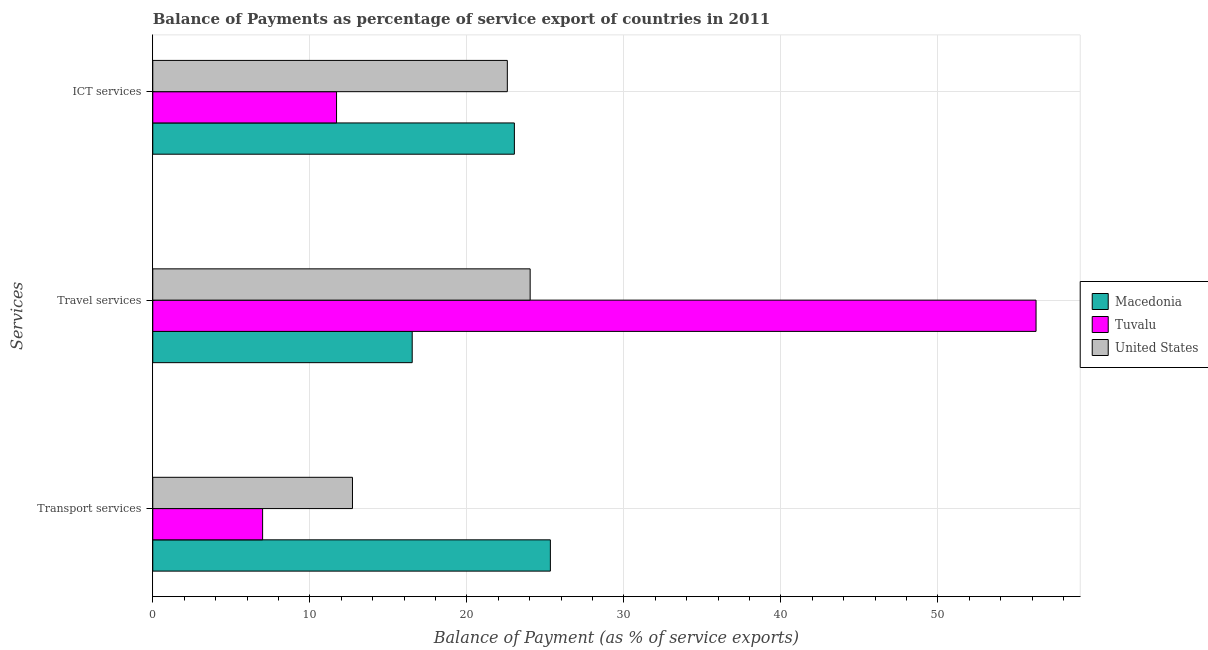How many different coloured bars are there?
Offer a terse response. 3. How many bars are there on the 3rd tick from the bottom?
Provide a short and direct response. 3. What is the label of the 1st group of bars from the top?
Offer a terse response. ICT services. What is the balance of payment of transport services in Macedonia?
Keep it short and to the point. 25.32. Across all countries, what is the maximum balance of payment of travel services?
Make the answer very short. 56.25. Across all countries, what is the minimum balance of payment of transport services?
Offer a very short reply. 6.99. In which country was the balance of payment of travel services maximum?
Offer a very short reply. Tuvalu. In which country was the balance of payment of transport services minimum?
Ensure brevity in your answer.  Tuvalu. What is the total balance of payment of transport services in the graph?
Keep it short and to the point. 45.03. What is the difference between the balance of payment of transport services in Tuvalu and that in Macedonia?
Your answer should be very brief. -18.32. What is the difference between the balance of payment of ict services in United States and the balance of payment of transport services in Macedonia?
Ensure brevity in your answer.  -2.74. What is the average balance of payment of ict services per country?
Provide a short and direct response. 19.1. What is the difference between the balance of payment of transport services and balance of payment of travel services in United States?
Ensure brevity in your answer.  -11.32. What is the ratio of the balance of payment of transport services in Macedonia to that in Tuvalu?
Give a very brief answer. 3.62. Is the balance of payment of transport services in United States less than that in Macedonia?
Your answer should be very brief. Yes. Is the difference between the balance of payment of transport services in United States and Macedonia greater than the difference between the balance of payment of travel services in United States and Macedonia?
Your answer should be very brief. No. What is the difference between the highest and the second highest balance of payment of transport services?
Your answer should be very brief. 12.6. What is the difference between the highest and the lowest balance of payment of transport services?
Make the answer very short. 18.32. What does the 2nd bar from the top in ICT services represents?
Offer a very short reply. Tuvalu. What does the 3rd bar from the bottom in ICT services represents?
Your response must be concise. United States. Is it the case that in every country, the sum of the balance of payment of transport services and balance of payment of travel services is greater than the balance of payment of ict services?
Make the answer very short. Yes. How many bars are there?
Provide a short and direct response. 9. How many countries are there in the graph?
Provide a succinct answer. 3. What is the difference between two consecutive major ticks on the X-axis?
Provide a short and direct response. 10. Does the graph contain any zero values?
Make the answer very short. No. Does the graph contain grids?
Your response must be concise. Yes. Where does the legend appear in the graph?
Offer a very short reply. Center right. How many legend labels are there?
Your answer should be compact. 3. How are the legend labels stacked?
Ensure brevity in your answer.  Vertical. What is the title of the graph?
Ensure brevity in your answer.  Balance of Payments as percentage of service export of countries in 2011. Does "Peru" appear as one of the legend labels in the graph?
Make the answer very short. No. What is the label or title of the X-axis?
Keep it short and to the point. Balance of Payment (as % of service exports). What is the label or title of the Y-axis?
Provide a succinct answer. Services. What is the Balance of Payment (as % of service exports) in Macedonia in Transport services?
Your answer should be very brief. 25.32. What is the Balance of Payment (as % of service exports) of Tuvalu in Transport services?
Offer a very short reply. 6.99. What is the Balance of Payment (as % of service exports) in United States in Transport services?
Make the answer very short. 12.72. What is the Balance of Payment (as % of service exports) in Macedonia in Travel services?
Your response must be concise. 16.52. What is the Balance of Payment (as % of service exports) in Tuvalu in Travel services?
Give a very brief answer. 56.25. What is the Balance of Payment (as % of service exports) of United States in Travel services?
Your answer should be very brief. 24.03. What is the Balance of Payment (as % of service exports) in Macedonia in ICT services?
Your response must be concise. 23.03. What is the Balance of Payment (as % of service exports) in Tuvalu in ICT services?
Provide a short and direct response. 11.7. What is the Balance of Payment (as % of service exports) in United States in ICT services?
Offer a very short reply. 22.58. Across all Services, what is the maximum Balance of Payment (as % of service exports) of Macedonia?
Ensure brevity in your answer.  25.32. Across all Services, what is the maximum Balance of Payment (as % of service exports) of Tuvalu?
Your answer should be very brief. 56.25. Across all Services, what is the maximum Balance of Payment (as % of service exports) in United States?
Make the answer very short. 24.03. Across all Services, what is the minimum Balance of Payment (as % of service exports) of Macedonia?
Provide a short and direct response. 16.52. Across all Services, what is the minimum Balance of Payment (as % of service exports) of Tuvalu?
Your answer should be compact. 6.99. Across all Services, what is the minimum Balance of Payment (as % of service exports) in United States?
Provide a succinct answer. 12.72. What is the total Balance of Payment (as % of service exports) in Macedonia in the graph?
Your response must be concise. 64.87. What is the total Balance of Payment (as % of service exports) in Tuvalu in the graph?
Provide a short and direct response. 74.94. What is the total Balance of Payment (as % of service exports) of United States in the graph?
Provide a succinct answer. 59.33. What is the difference between the Balance of Payment (as % of service exports) of Macedonia in Transport services and that in Travel services?
Make the answer very short. 8.8. What is the difference between the Balance of Payment (as % of service exports) in Tuvalu in Transport services and that in Travel services?
Offer a very short reply. -49.25. What is the difference between the Balance of Payment (as % of service exports) of United States in Transport services and that in Travel services?
Give a very brief answer. -11.32. What is the difference between the Balance of Payment (as % of service exports) in Macedonia in Transport services and that in ICT services?
Offer a very short reply. 2.29. What is the difference between the Balance of Payment (as % of service exports) of Tuvalu in Transport services and that in ICT services?
Give a very brief answer. -4.71. What is the difference between the Balance of Payment (as % of service exports) in United States in Transport services and that in ICT services?
Your answer should be compact. -9.86. What is the difference between the Balance of Payment (as % of service exports) in Macedonia in Travel services and that in ICT services?
Give a very brief answer. -6.51. What is the difference between the Balance of Payment (as % of service exports) of Tuvalu in Travel services and that in ICT services?
Provide a short and direct response. 44.54. What is the difference between the Balance of Payment (as % of service exports) of United States in Travel services and that in ICT services?
Your answer should be very brief. 1.45. What is the difference between the Balance of Payment (as % of service exports) in Macedonia in Transport services and the Balance of Payment (as % of service exports) in Tuvalu in Travel services?
Provide a succinct answer. -30.93. What is the difference between the Balance of Payment (as % of service exports) of Macedonia in Transport services and the Balance of Payment (as % of service exports) of United States in Travel services?
Your response must be concise. 1.29. What is the difference between the Balance of Payment (as % of service exports) in Tuvalu in Transport services and the Balance of Payment (as % of service exports) in United States in Travel services?
Your answer should be compact. -17.04. What is the difference between the Balance of Payment (as % of service exports) in Macedonia in Transport services and the Balance of Payment (as % of service exports) in Tuvalu in ICT services?
Make the answer very short. 13.62. What is the difference between the Balance of Payment (as % of service exports) in Macedonia in Transport services and the Balance of Payment (as % of service exports) in United States in ICT services?
Provide a succinct answer. 2.74. What is the difference between the Balance of Payment (as % of service exports) in Tuvalu in Transport services and the Balance of Payment (as % of service exports) in United States in ICT services?
Offer a terse response. -15.58. What is the difference between the Balance of Payment (as % of service exports) in Macedonia in Travel services and the Balance of Payment (as % of service exports) in Tuvalu in ICT services?
Give a very brief answer. 4.82. What is the difference between the Balance of Payment (as % of service exports) in Macedonia in Travel services and the Balance of Payment (as % of service exports) in United States in ICT services?
Ensure brevity in your answer.  -6.06. What is the difference between the Balance of Payment (as % of service exports) in Tuvalu in Travel services and the Balance of Payment (as % of service exports) in United States in ICT services?
Your response must be concise. 33.67. What is the average Balance of Payment (as % of service exports) of Macedonia per Services?
Offer a very short reply. 21.62. What is the average Balance of Payment (as % of service exports) of Tuvalu per Services?
Give a very brief answer. 24.98. What is the average Balance of Payment (as % of service exports) in United States per Services?
Provide a short and direct response. 19.78. What is the difference between the Balance of Payment (as % of service exports) in Macedonia and Balance of Payment (as % of service exports) in Tuvalu in Transport services?
Make the answer very short. 18.32. What is the difference between the Balance of Payment (as % of service exports) in Macedonia and Balance of Payment (as % of service exports) in United States in Transport services?
Your answer should be compact. 12.6. What is the difference between the Balance of Payment (as % of service exports) of Tuvalu and Balance of Payment (as % of service exports) of United States in Transport services?
Provide a short and direct response. -5.72. What is the difference between the Balance of Payment (as % of service exports) of Macedonia and Balance of Payment (as % of service exports) of Tuvalu in Travel services?
Offer a very short reply. -39.73. What is the difference between the Balance of Payment (as % of service exports) in Macedonia and Balance of Payment (as % of service exports) in United States in Travel services?
Offer a very short reply. -7.51. What is the difference between the Balance of Payment (as % of service exports) in Tuvalu and Balance of Payment (as % of service exports) in United States in Travel services?
Keep it short and to the point. 32.22. What is the difference between the Balance of Payment (as % of service exports) of Macedonia and Balance of Payment (as % of service exports) of Tuvalu in ICT services?
Your answer should be compact. 11.32. What is the difference between the Balance of Payment (as % of service exports) of Macedonia and Balance of Payment (as % of service exports) of United States in ICT services?
Ensure brevity in your answer.  0.45. What is the difference between the Balance of Payment (as % of service exports) of Tuvalu and Balance of Payment (as % of service exports) of United States in ICT services?
Offer a terse response. -10.88. What is the ratio of the Balance of Payment (as % of service exports) in Macedonia in Transport services to that in Travel services?
Offer a terse response. 1.53. What is the ratio of the Balance of Payment (as % of service exports) in Tuvalu in Transport services to that in Travel services?
Give a very brief answer. 0.12. What is the ratio of the Balance of Payment (as % of service exports) of United States in Transport services to that in Travel services?
Provide a succinct answer. 0.53. What is the ratio of the Balance of Payment (as % of service exports) in Macedonia in Transport services to that in ICT services?
Your answer should be compact. 1.1. What is the ratio of the Balance of Payment (as % of service exports) in Tuvalu in Transport services to that in ICT services?
Keep it short and to the point. 0.6. What is the ratio of the Balance of Payment (as % of service exports) of United States in Transport services to that in ICT services?
Your response must be concise. 0.56. What is the ratio of the Balance of Payment (as % of service exports) in Macedonia in Travel services to that in ICT services?
Your answer should be very brief. 0.72. What is the ratio of the Balance of Payment (as % of service exports) in Tuvalu in Travel services to that in ICT services?
Make the answer very short. 4.81. What is the ratio of the Balance of Payment (as % of service exports) in United States in Travel services to that in ICT services?
Make the answer very short. 1.06. What is the difference between the highest and the second highest Balance of Payment (as % of service exports) of Macedonia?
Keep it short and to the point. 2.29. What is the difference between the highest and the second highest Balance of Payment (as % of service exports) in Tuvalu?
Make the answer very short. 44.54. What is the difference between the highest and the second highest Balance of Payment (as % of service exports) of United States?
Your answer should be compact. 1.45. What is the difference between the highest and the lowest Balance of Payment (as % of service exports) of Macedonia?
Ensure brevity in your answer.  8.8. What is the difference between the highest and the lowest Balance of Payment (as % of service exports) of Tuvalu?
Ensure brevity in your answer.  49.25. What is the difference between the highest and the lowest Balance of Payment (as % of service exports) in United States?
Give a very brief answer. 11.32. 